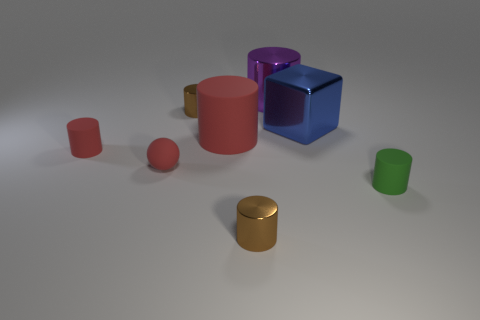There is a small object that is the same color as the rubber sphere; what shape is it?
Ensure brevity in your answer.  Cylinder. There is a purple shiny object; does it have the same size as the cylinder that is right of the big purple metal cylinder?
Offer a terse response. No. What number of things are tiny red rubber things or gray matte spheres?
Ensure brevity in your answer.  2. Are there any other small blue blocks made of the same material as the cube?
Ensure brevity in your answer.  No. The other rubber cylinder that is the same color as the big matte cylinder is what size?
Give a very brief answer. Small. What is the color of the metal thing that is behind the tiny cylinder behind the big red rubber cylinder?
Keep it short and to the point. Purple. Is the size of the block the same as the red ball?
Offer a terse response. No. How many cubes are either small red matte objects or red things?
Provide a succinct answer. 0. There is a rubber cylinder on the right side of the big red rubber object; what number of cubes are to the right of it?
Provide a succinct answer. 0. Is the shape of the big purple metallic thing the same as the large blue shiny object?
Your answer should be compact. No. 